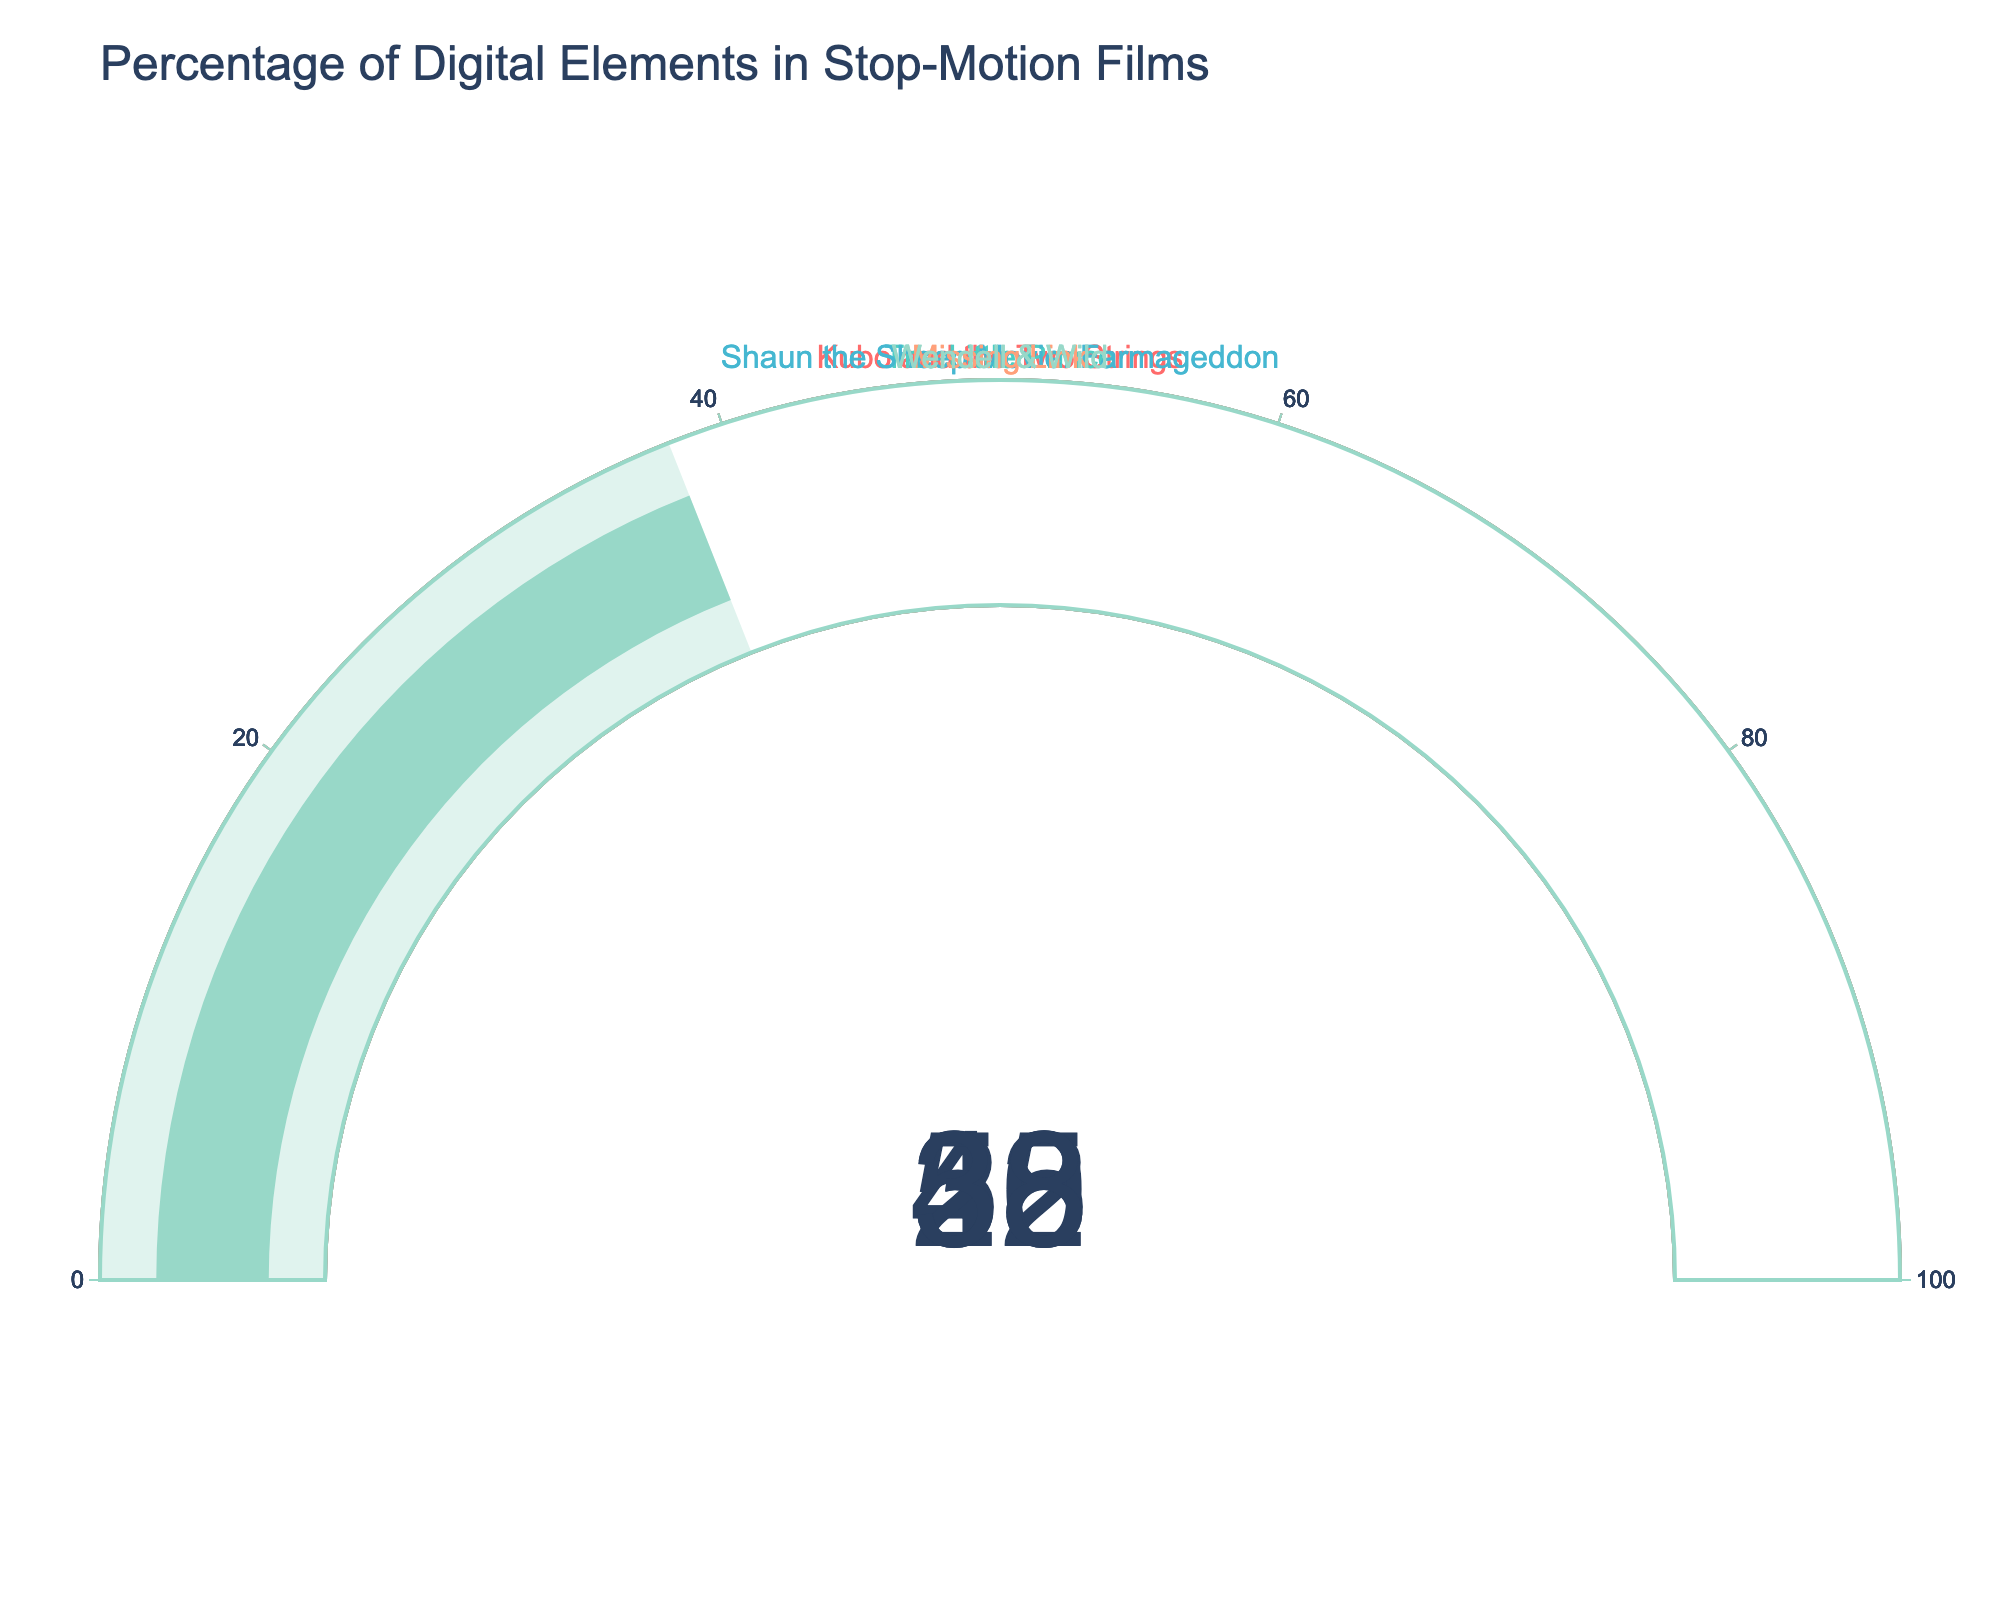What's the title of the figure? The title is usually displayed prominently at the top of the figure. Here, it reads "Percentage of Digital Elements in Stop-Motion Films".
Answer: Percentage of Digital Elements in Stop-Motion Films How many stop-motion films are represented in the figure? Each gauge represents one stop-motion film, and by counting the gauges, you can see that there are five films represented.
Answer: 5 Which film has incorporated the highest percentage of digital elements? By comparing the values displayed on each gauge, "Missing Link" shows the highest percentage at 50%.
Answer: Missing Link What is the average percentage of digital elements across all the films? Sum the percentages of all the films (35 + 42 + 28 + 50 + 38) = 193%. Then, divide by the number of films which is 5: 193 / 5 = 38.6%.
Answer: 38.6% Which film has the lowest percentage of digital elements, and what is it? By comparing each value, "Shaun the Sheep Movie: Farmageddon" has the lowest value of 28%.
Answer: Shaun the Sheep Movie: Farmageddon, 28% What's the difference in the percentage of digital elements between "The Little Prince" and "Missing Link"? Subtract the percentage of "The Little Prince" (42%) from "Missing Link" (50%): 50% - 42% = 8%.
Answer: 8% Are any two films incorporating an equal percentage of digital elements? Checking each gauge for equal values reveals that no two films have the same percentage.
Answer: No Which film has a percentage of digital elements closest to the midpoint (50%) and how close is it? "Missing Link" has a percentage of 50%, making it exactly at the midpoint.
Answer: Missing Link, 0% What's the combined percentage of digital elements for "Kubo and the Two Strings" and "Wendell & Wild"? Add the percentages for "Kubo and the Two Strings" (35%) and "Wendell & Wild" (38%): 35% + 38% = 73%.
Answer: 73% By how much does "Wendell & Wild" exceed "Shaun the Sheep Movie: Farmageddon" in terms of digital elements percentage? Subtract the percentage of "Shaun the Sheep Movie: Farmageddon" (28%) from "Wendell & Wild" (38%): 38% - 28% = 10%.
Answer: 10% 